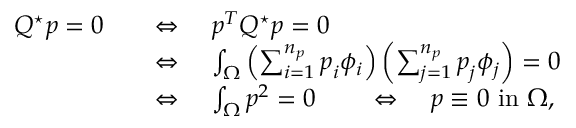Convert formula to latex. <formula><loc_0><loc_0><loc_500><loc_500>\begin{array} { r l } { Q ^ { ^ { * } } p = 0 \quad } & { \Leftrightarrow \quad p ^ { T } Q ^ { ^ { * } } p = 0 } \\ & { \Leftrightarrow \quad \int _ { \Omega } \left ( \sum _ { i = 1 } ^ { n _ { p } } p _ { i } \phi _ { i } \right ) \left ( \sum _ { j = 1 } ^ { n _ { p } } p _ { j } \phi _ { j } \right ) = 0 } \\ & { \Leftrightarrow \quad \int _ { \Omega } p ^ { 2 } = 0 \quad \Leftrightarrow \quad p \equiv 0 i n \Omega , } \end{array}</formula> 